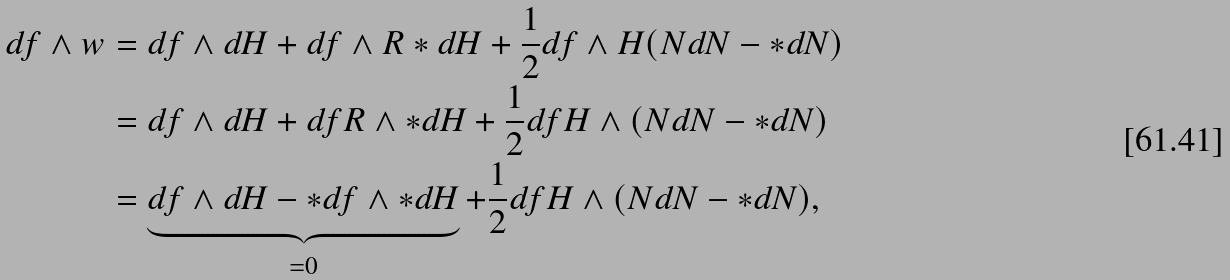<formula> <loc_0><loc_0><loc_500><loc_500>d f \wedge w & = d f \wedge d H + d f \wedge R * d H + \frac { 1 } { 2 } d f \wedge H ( N d N - * d N ) \\ & = d f \wedge d H + d f R \wedge * d H + \frac { 1 } { 2 } d f H \wedge ( N d N - * d N ) \\ & = \underbrace { d f \wedge d H - * d f \wedge * d H } _ { = 0 } + \frac { 1 } { 2 } d f H \wedge ( N d N - * d N ) ,</formula> 